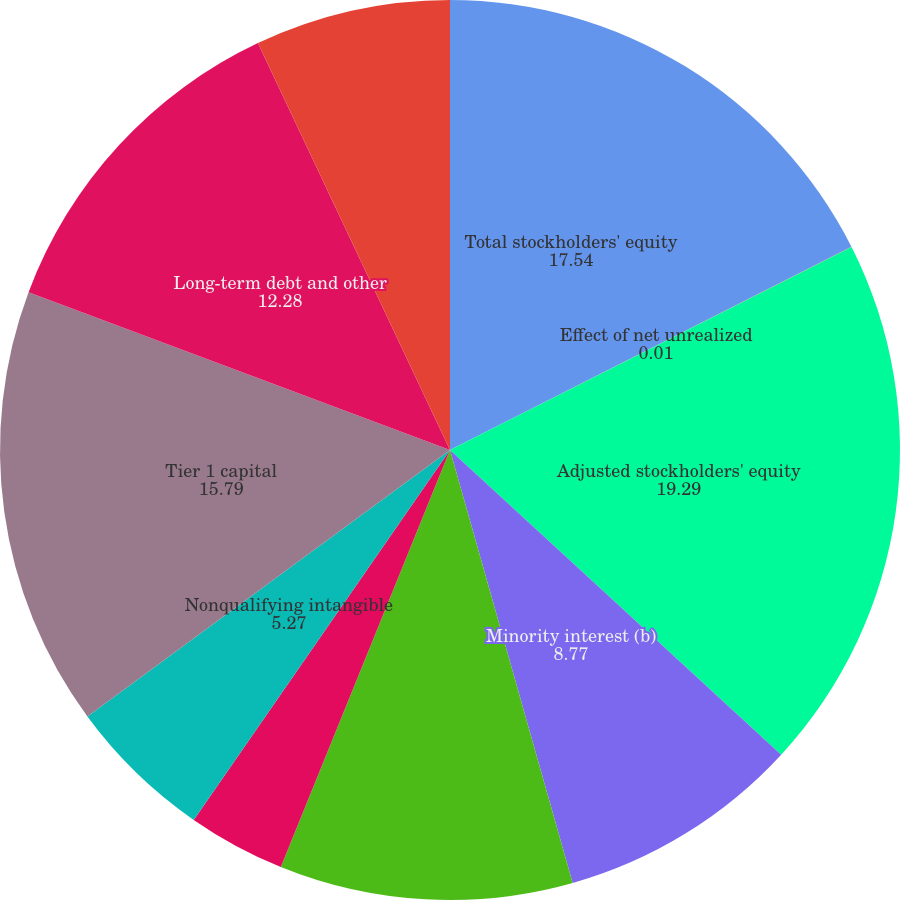Convert chart. <chart><loc_0><loc_0><loc_500><loc_500><pie_chart><fcel>Total stockholders' equity<fcel>Effect of net unrealized<fcel>Adjusted stockholders' equity<fcel>Minority interest (b)<fcel>Less Goodwill<fcel>Investments in certain<fcel>Nonqualifying intangible<fcel>Tier 1 capital<fcel>Long-term debt and other<fcel>Qualifying allowance for<nl><fcel>17.54%<fcel>0.01%<fcel>19.29%<fcel>8.77%<fcel>10.53%<fcel>3.51%<fcel>5.27%<fcel>15.79%<fcel>12.28%<fcel>7.02%<nl></chart> 